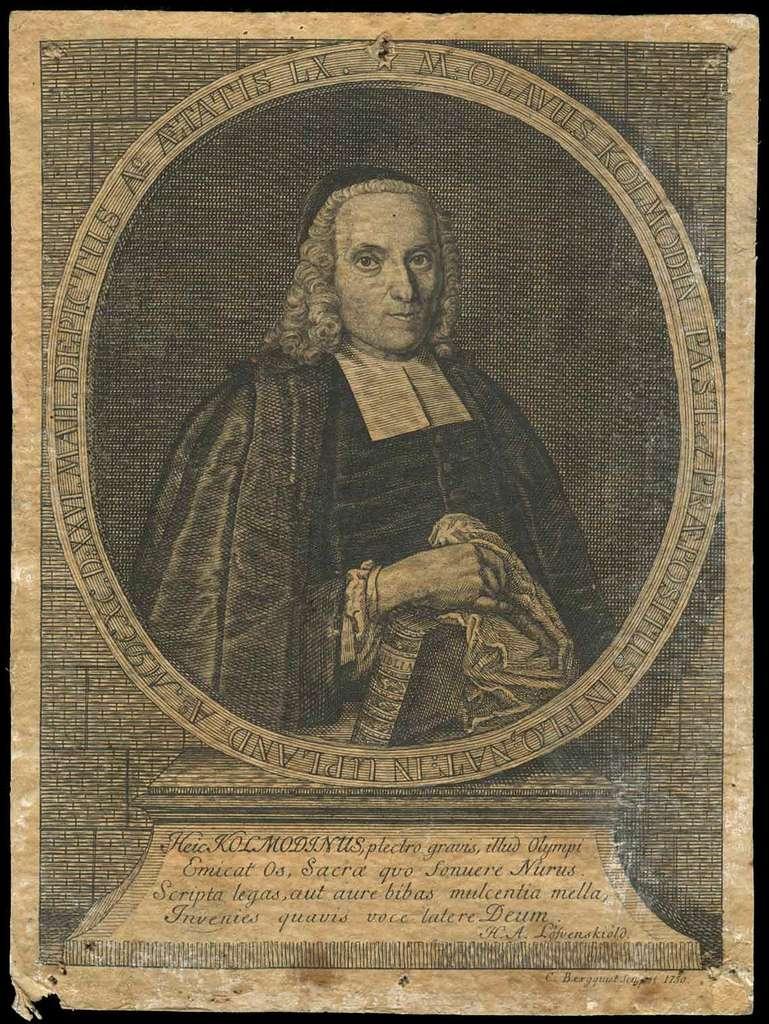Is this quote written in latin?
Your answer should be compact. Yes. What language is the quote written?
Give a very brief answer. Latin. 